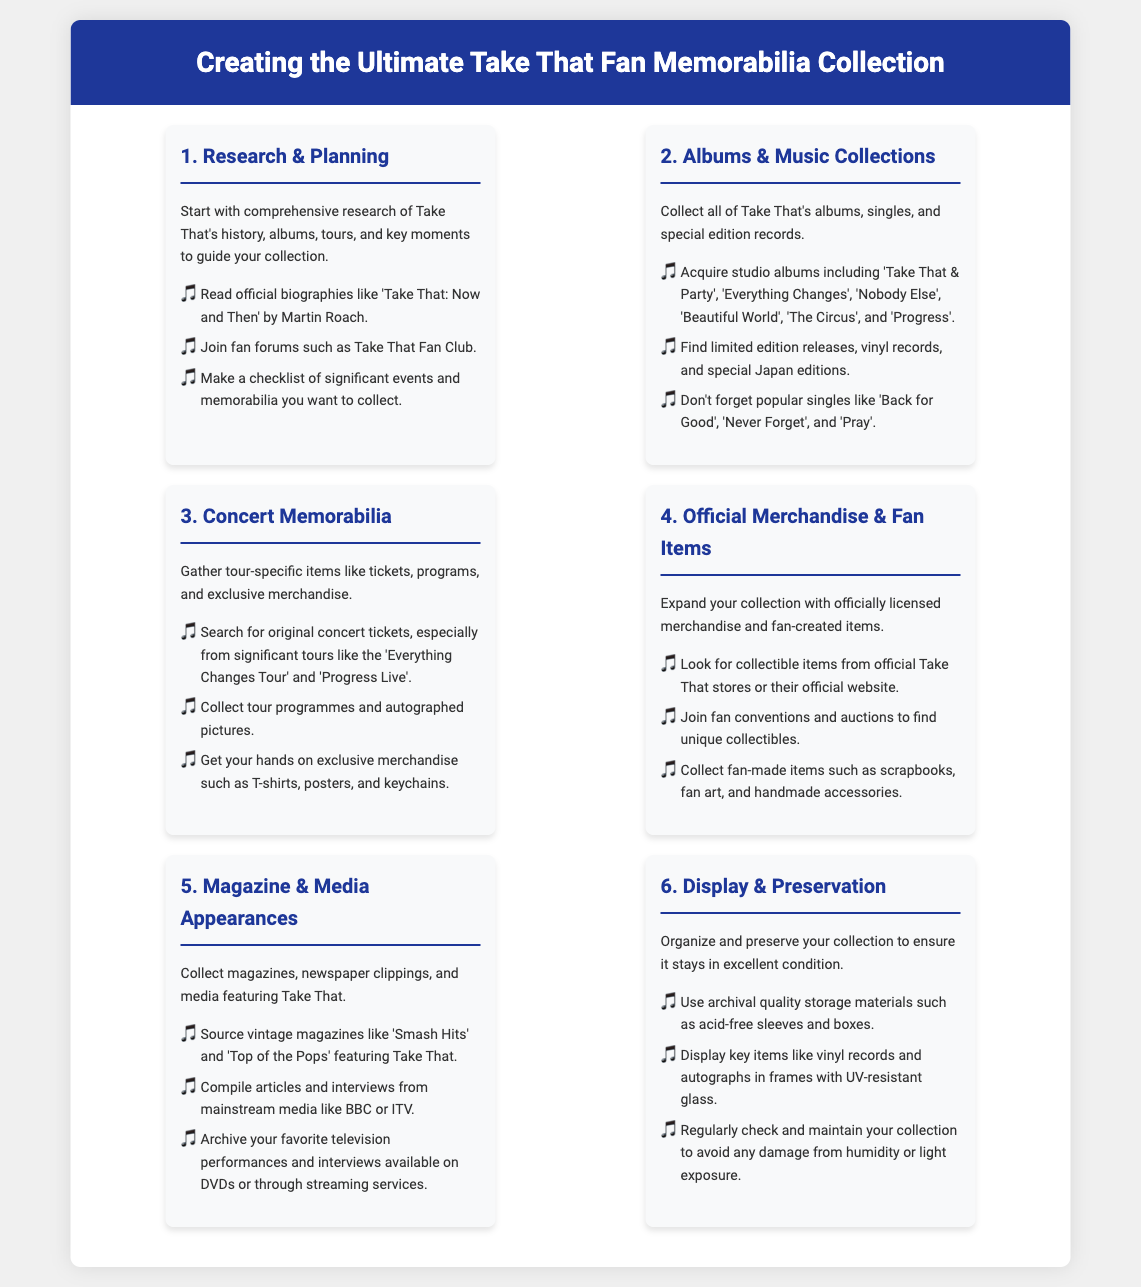what is the title of the infographic? The title of the infographic is prominently displayed at the top, introducing the overall theme of the collection process.
Answer: Creating the Ultimate Take That Fan Memorabilia Collection how many steps are there in the process? The infographic outlines a total of six steps to create a memorabilia collection.
Answer: 6 what is the first step in creating the collection? The first step is crucial for establishing a foundation for the collection and involves initial research.
Answer: Research & Planning name one album to collect from Take That. The document lists multiple albums, indicating significant works from Take That over the years.
Answer: Take That & Party what type of memorabilia is suggested to gather from concerts? Concert-specific items provide fans with tangible connections to their experiences at events.
Answer: tickets where can you find collectible items? The document suggests various sources for collectible items, emphasizing the role of official merchandise.
Answer: official Take That stores what is one key to maintaining the collection's condition? The preservation of memorabilia ensures longevity and prevents damage, which is important for any collection.
Answer: archival quality storage materials which magazines are recommended to collect? Collecting vintage publications helps in creating a comprehensive archive of the band's media presence.
Answer: Smash Hits what is a type of fan-created item to collect? Fan creativity leads to unique and personal additions to any collection, making it special.
Answer: scrapbooks 